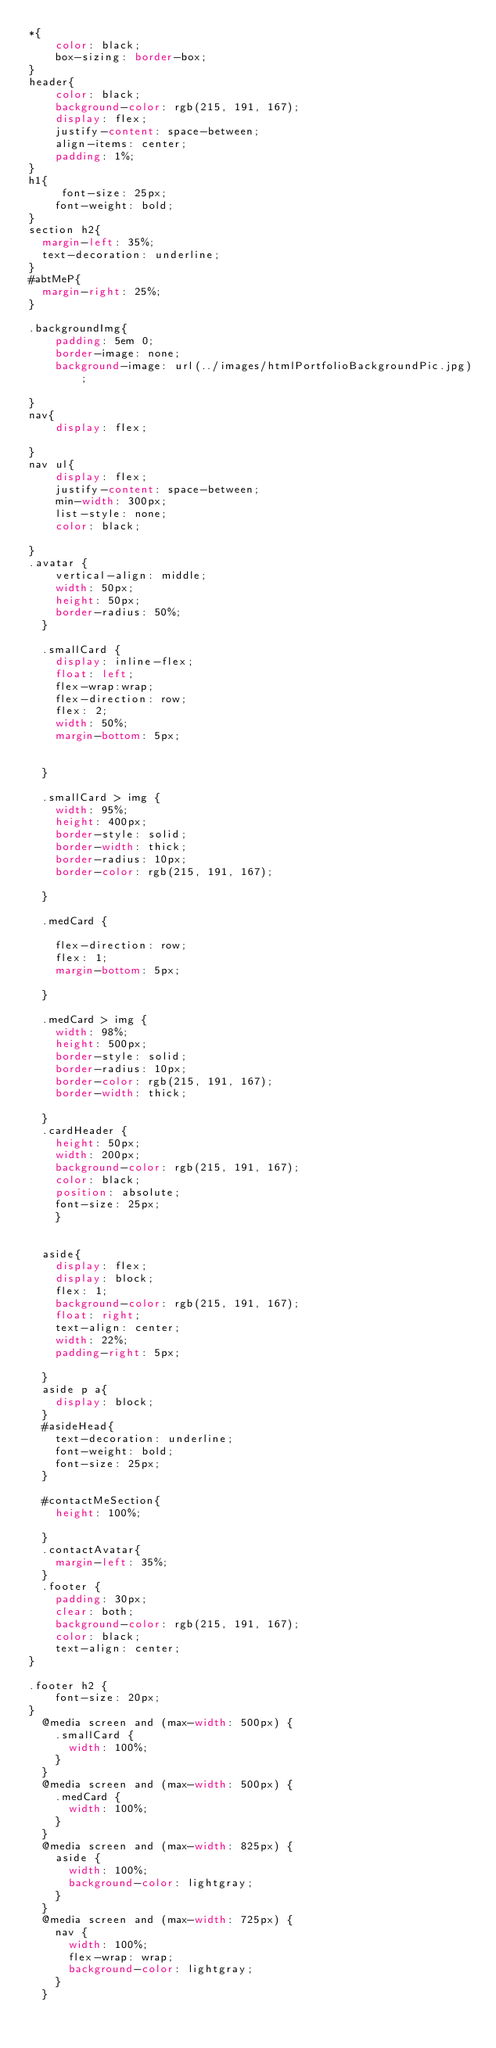<code> <loc_0><loc_0><loc_500><loc_500><_CSS_>*{
    color: black;
    box-sizing: border-box;
}
header{
    color: black;
    background-color: rgb(215, 191, 167);
    display: flex;
    justify-content: space-between;
    align-items: center;
    padding: 1%;
}
h1{
     font-size: 25px;
    font-weight: bold;
}
section h2{
  margin-left: 35%;
  text-decoration: underline;
}
#abtMeP{
  margin-right: 25%;
}
    
.backgroundImg{
    padding: 5em 0;
    border-image: none;
    background-image: url(../images/htmlPortfolioBackgroundPic.jpg);
    
}
nav{
    display: flex;
    
}
nav ul{
    display: flex;
    justify-content: space-between;
    min-width: 300px;
    list-style: none;
    color: black;

}
.avatar {
    vertical-align: middle;
    width: 50px;
    height: 50px;
    border-radius: 50%;
  }
  
  .smallCard {
    display: inline-flex;
    float: left;
    flex-wrap:wrap;
    flex-direction: row;
    flex: 2;
    width: 50%;
    margin-bottom: 5px;
   
  
  }

  .smallCard > img {
    width: 95%;
    height: 400px;
    border-style: solid;
    border-width: thick;
    border-radius: 10px;
    border-color: rgb(215, 191, 167);
  
  }  
 
  .medCard {
    
    flex-direction: row;
    flex: 1;
    margin-bottom: 5px;
    
  }
  
  .medCard > img {
    width: 98%;
    height: 500px;
    border-style: solid;
    border-radius: 10px;
    border-color: rgb(215, 191, 167);
    border-width: thick;
    
  }
  .cardHeader {
    height: 50px;
    width: 200px;
    background-color: rgb(215, 191, 167);
    color: black;
    position: absolute;
    font-size: 25px;
    }
    
 
  aside{
    display: flex;
    display: block;
    flex: 1;
    background-color: rgb(215, 191, 167);
    float: right;
    text-align: center;
    width: 22%;
    padding-right: 5px;
  
  }
  aside p a{
    display: block;
  }
  #asideHead{
    text-decoration: underline;
    font-weight: bold;
    font-size: 25px;
  }
 
  #contactMeSection{
    height: 100%;

  }
  .contactAvatar{
    margin-left: 35%;
  }
  .footer {
    padding: 30px;
    clear: both;
    background-color: rgb(215, 191, 167);
    color: black;
    text-align: center;
}

.footer h2 {
    font-size: 20px;
}
  @media screen and (max-width: 500px) {
    .smallCard {
      width: 100%;
    }
  }
  @media screen and (max-width: 500px) {
    .medCard {
      width: 100%;
    }
  }
  @media screen and (max-width: 825px) {
    aside {
      width: 100%;
      background-color: lightgray;
    }
  }
  @media screen and (max-width: 725px) {
    nav {
      width: 100%;
      flex-wrap: wrap;
      background-color: lightgray;
    }
  }
  </code> 